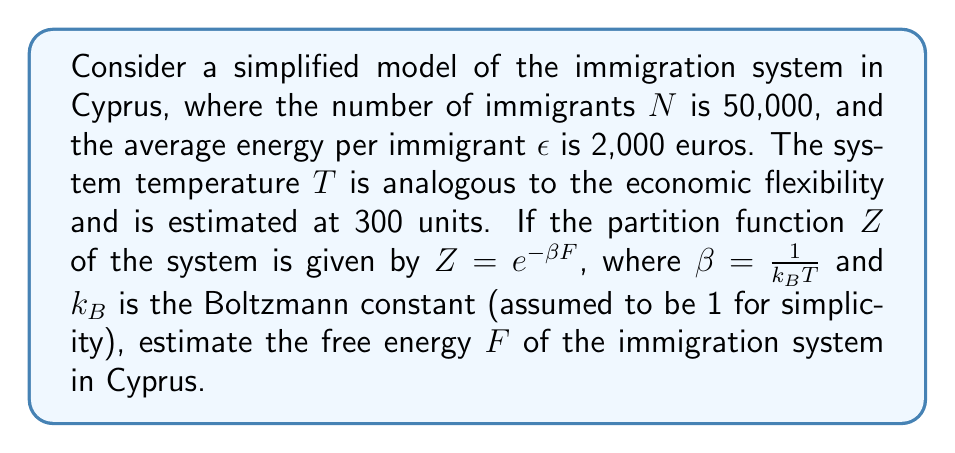What is the answer to this math problem? To estimate the free energy of the immigration system, we'll follow these steps:

1) First, recall the relationship between free energy $F$, energy $E$, temperature $T$, and entropy $S$:

   $$F = E - TS$$

2) In our simplified model, the total energy $E$ is the product of the number of immigrants and the average energy per immigrant:

   $$E = N\epsilon = 50,000 \times 2,000 = 100,000,000 \text{ euros}$$

3) We don't have direct information about the entropy, but we can use the partition function to calculate the free energy. The partition function is given by:

   $$Z = e^{-\beta F}$$

4) Taking the natural logarithm of both sides:

   $$\ln Z = -\beta F$$

5) Rearranging to solve for $F$:

   $$F = -\frac{1}{\beta} \ln Z$$

6) We know that $\beta = \frac{1}{k_B T}$, and we've assumed $k_B = 1$ for simplicity. So:

   $$\beta = \frac{1}{300}$$

7) We don't have a specific value for $Z$, but in many systems, $Z$ is often of the order of $e^N$. Let's assume this is the case here:

   $$Z \approx e^{50,000}$$

8) Now we can estimate $F$:

   $$F = -300 \ln(e^{50,000}) = -300 \times 50,000 = -15,000,000$$

Therefore, the estimated free energy of the immigration system is -15,000,000 units (which would be interpreted as euros in this context).
Answer: $F \approx -15,000,000$ euros 